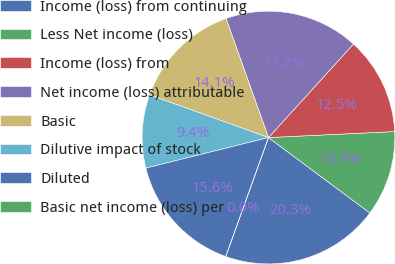Convert chart to OTSL. <chart><loc_0><loc_0><loc_500><loc_500><pie_chart><fcel>Income (loss) from continuing<fcel>Less Net income (loss)<fcel>Income (loss) from<fcel>Net income (loss) attributable<fcel>Basic<fcel>Dilutive impact of stock<fcel>Diluted<fcel>Basic net income (loss) per<nl><fcel>20.31%<fcel>10.94%<fcel>12.5%<fcel>17.19%<fcel>14.06%<fcel>9.38%<fcel>15.62%<fcel>0.0%<nl></chart> 